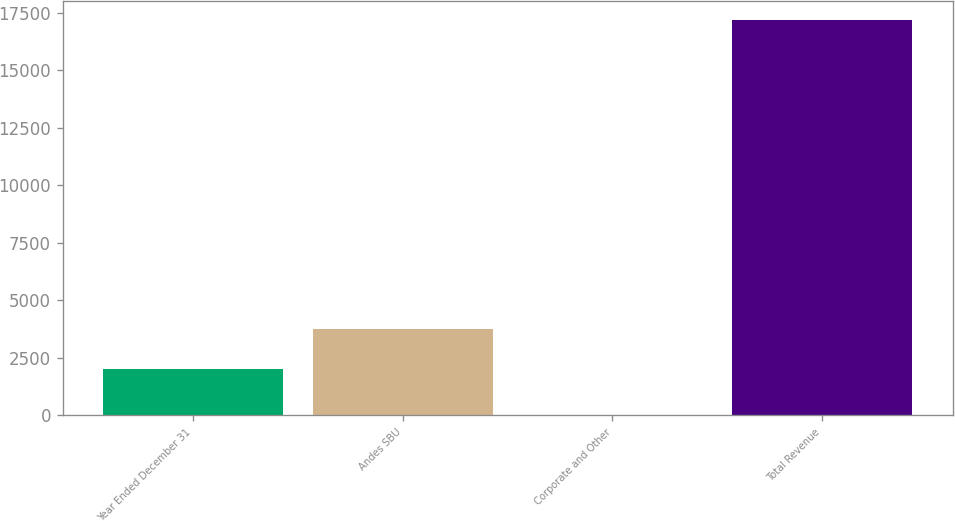Convert chart to OTSL. <chart><loc_0><loc_0><loc_500><loc_500><bar_chart><fcel>Year Ended December 31<fcel>Andes SBU<fcel>Corporate and Other<fcel>Total Revenue<nl><fcel>2014<fcel>3729.6<fcel>15<fcel>17171<nl></chart> 